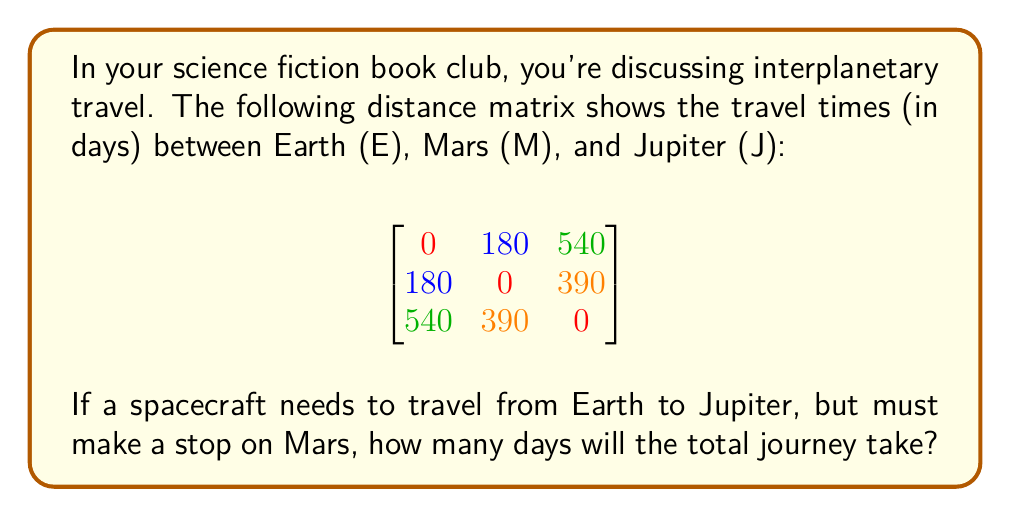Provide a solution to this math problem. Let's approach this step-by-step:

1) First, we need to understand what the matrix represents:
   - The rows and columns represent Earth (E), Mars (M), and Jupiter (J) in that order.
   - Each entry shows the travel time in days between two planets.

2) We need to find two values:
   a) Travel time from Earth to Mars
   b) Travel time from Mars to Jupiter

3) From the matrix:
   a) Earth to Mars (E to M) = 180 days (1st row, 2nd column)
   b) Mars to Jupiter (M to J) = 390 days (2nd row, 3rd column)

4) To get the total travel time, we add these values:
   
   $$ \text{Total time} = 180 + 390 = 570 \text{ days} $$

Therefore, the total journey from Earth to Jupiter with a stop on Mars will take 570 days.
Answer: 570 days 